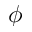<formula> <loc_0><loc_0><loc_500><loc_500>\phi</formula> 